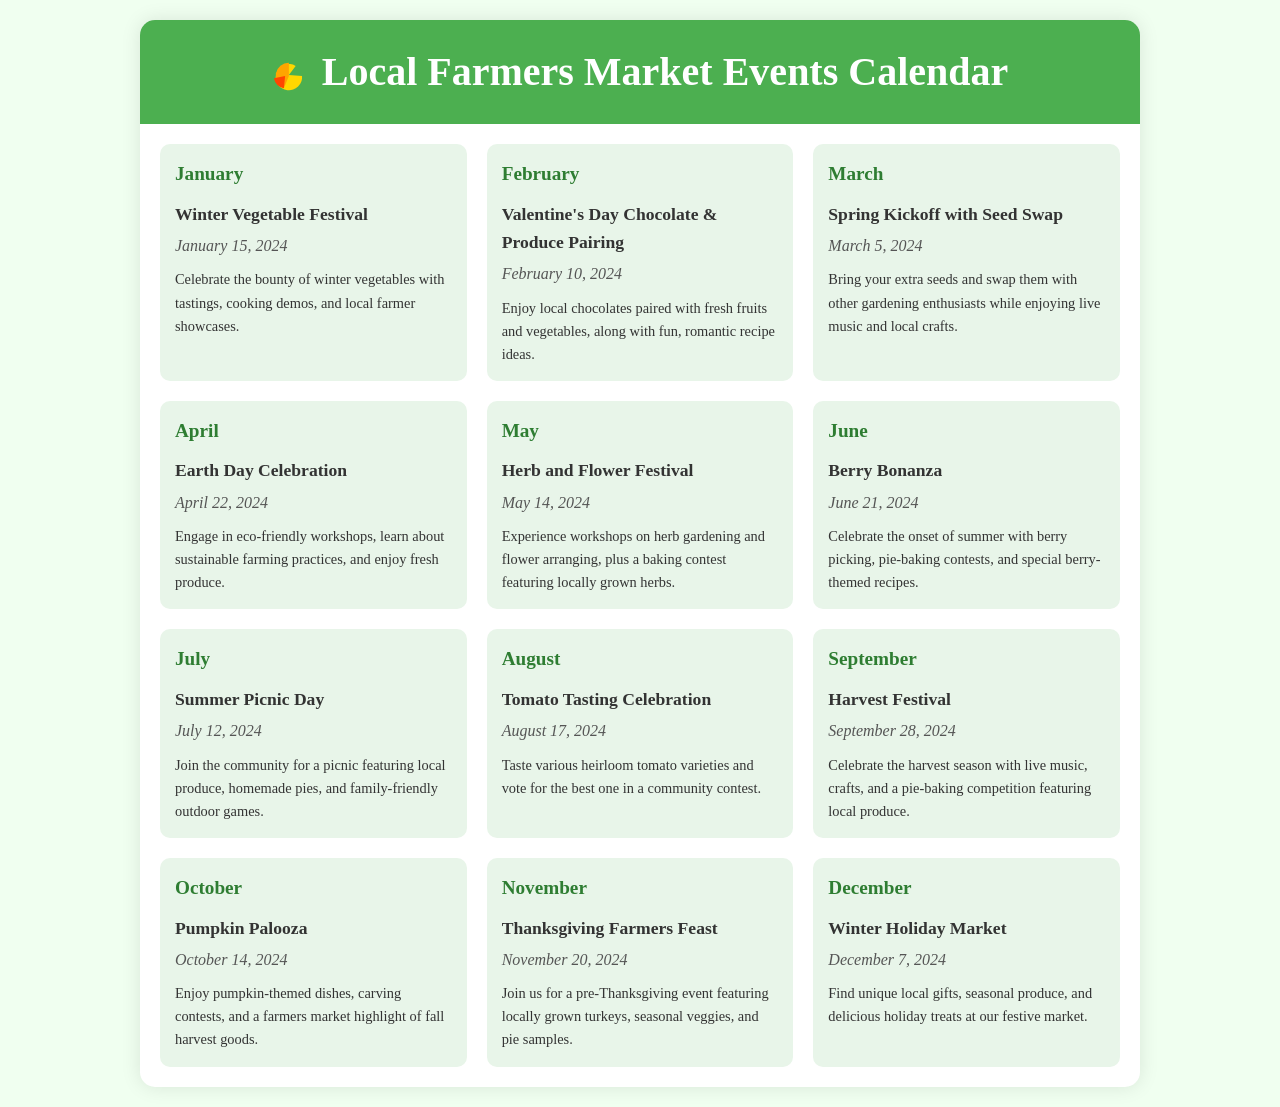what is the first event scheduled in the calendar? The first event listed is the Winter Vegetable Festival taking place on January 15, 2024.
Answer: Winter Vegetable Festival when is the Valentine's Day event? The Valentine's Day event is scheduled for February 10, 2024.
Answer: February 10, 2024 what event involves a baking contest in June? The June event that includes a baking contest is the Berry Bonanza, featuring pie-baking contests.
Answer: Berry Bonanza which event features a seed swap? The March event featuring a seed swap is the Spring Kickoff with Seed Swap.
Answer: Spring Kickoff with Seed Swap how many events take place during the summer months? The summer months include June and July, with two events scheduled: Berry Bonanza and Summer Picnic Day.
Answer: 2 